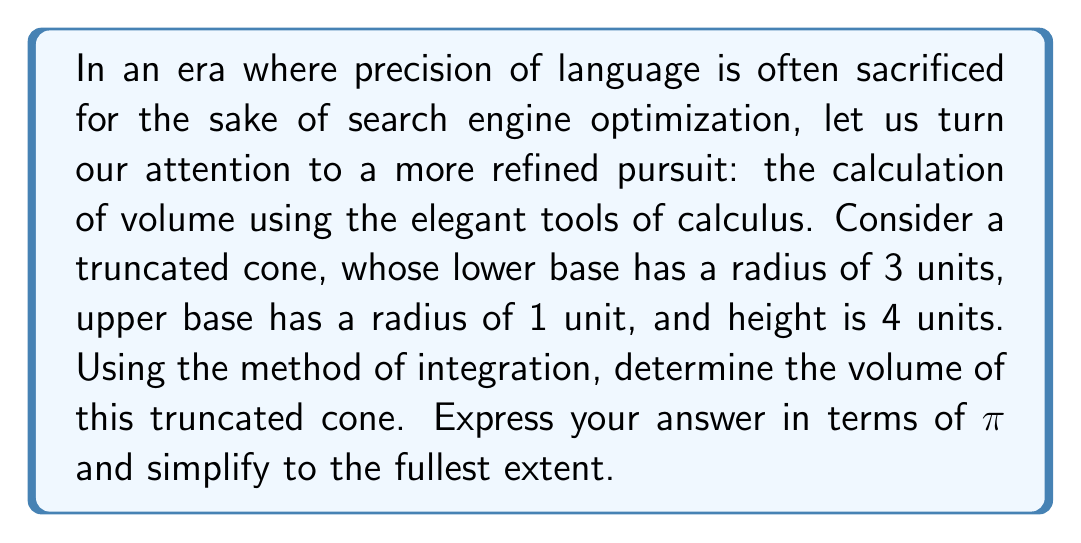Help me with this question. To calculate the volume of a truncated cone using integration, we shall proceed with the following steps:

1) First, let us visualize the truncated cone:

[asy]
import geometry;

size(200);
real r1 = 3, r2 = 1, h = 4;
pair A = (0,0), B = (r1,0), C = (r2,h), D = (0,h);
draw(A--B--C--D--cycle);
draw(B--(r2,0),dashed);
label("r₁=3", (r1/2,-0.5));
label("r₂=1", (r2/2,h+0.5));
label("h=4", (-0.5,h/2));
[/asy]

2) The volume of a solid of revolution can be calculated using the formula:

$$V = \int_a^b \pi [R(x)]^2 dx$$

where $R(x)$ is the radius of the cross-section at height $x$.

3) For a truncated cone, the radius at any height $x$ can be expressed as:

$$R(x) = r_1 - \frac{r_1 - r_2}{h}x$$

where $r_1$ is the radius of the lower base, $r_2$ is the radius of the upper base, and $h$ is the height.

4) Substituting the given values:

$$R(x) = 3 - \frac{3 - 1}{4}x = 3 - \frac{1}{2}x$$

5) Now, we can set up our integral:

$$V = \int_0^4 \pi (3 - \frac{1}{2}x)^2 dx$$

6) Expanding the integrand:

$$V = \pi \int_0^4 (9 - 3x + \frac{1}{4}x^2) dx$$

7) Integrating:

$$V = \pi [9x - \frac{3}{2}x^2 + \frac{1}{12}x^3]_0^4$$

8) Evaluating the definite integral:

$$V = \pi [(36 - 24 + \frac{16}{3}) - (0 - 0 + 0)]$$

9) Simplifying:

$$V = \pi (36 - 24 + \frac{16}{3}) = \pi (12 + \frac{16}{3}) = \pi (\frac{36}{3} + \frac{16}{3}) = \pi \frac{52}{3}$$

Thus, we arrive at our final answer.
Answer: The volume of the truncated cone is $\frac{52\pi}{3}$ cubic units. 